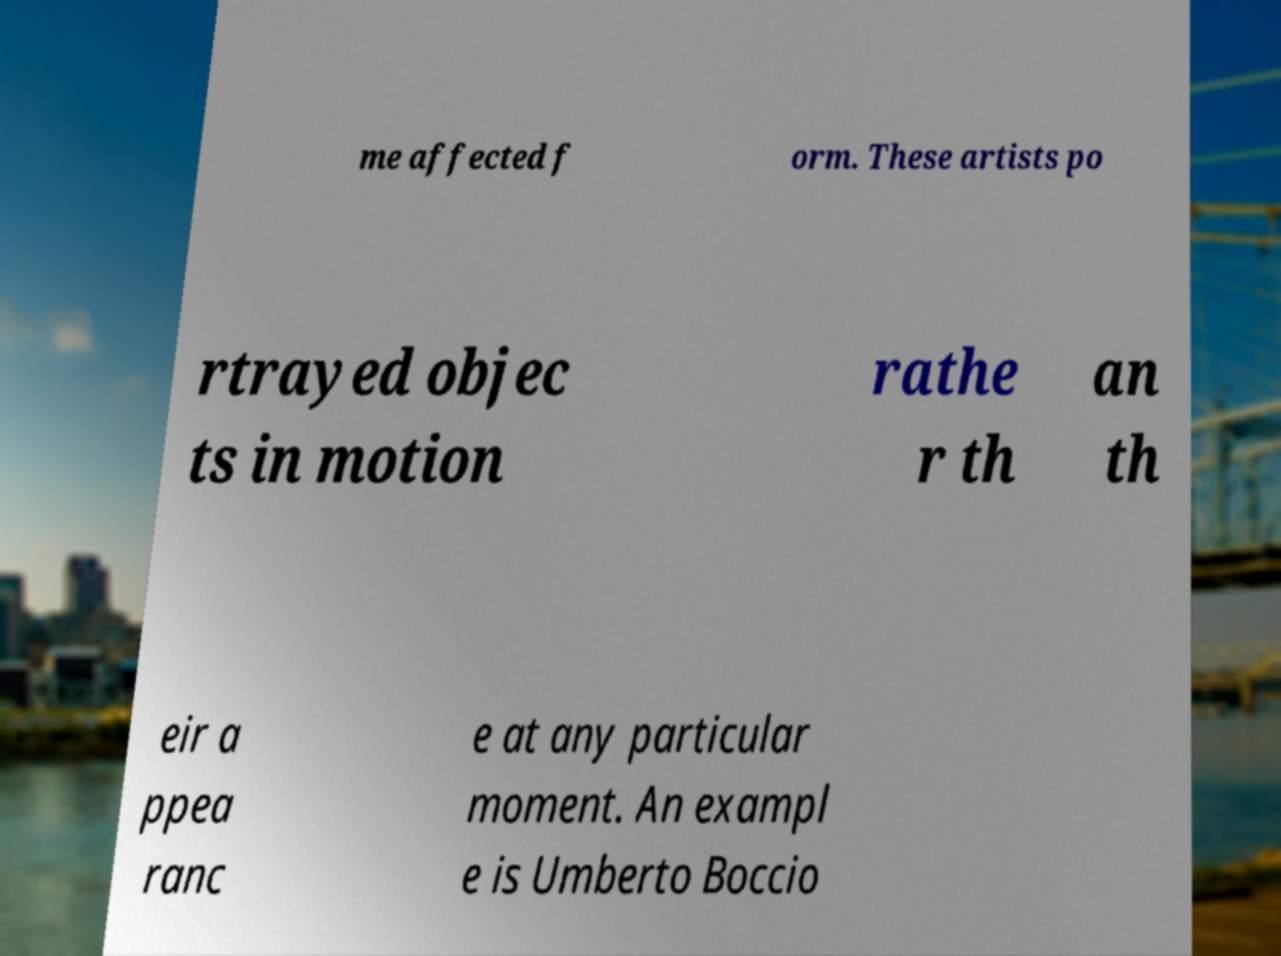Can you accurately transcribe the text from the provided image for me? me affected f orm. These artists po rtrayed objec ts in motion rathe r th an th eir a ppea ranc e at any particular moment. An exampl e is Umberto Boccio 